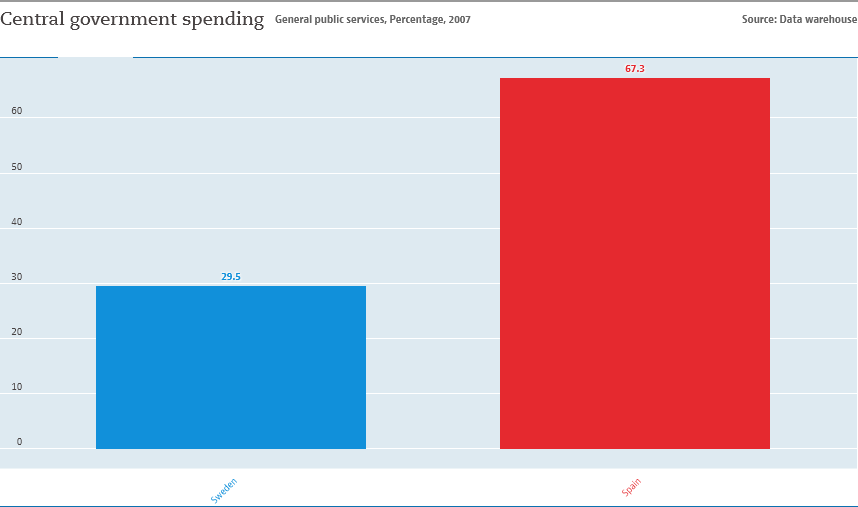Draw attention to some important aspects in this diagram. I am comparing Sweden and Spain in these two countries. The data for Spain is greater than the data for Sweden by 2.28 times. 